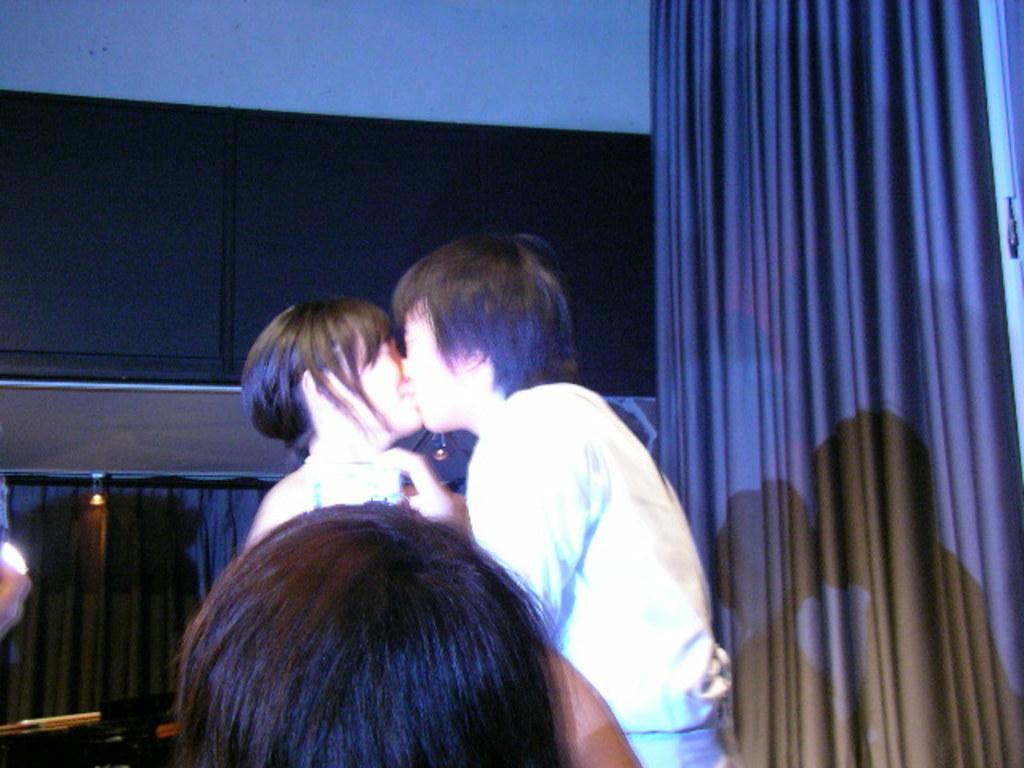Can you describe this image briefly? In this image there are two persons kissing each other, in front him there is a person, in the background there is a wall on the left there is a curtain. 